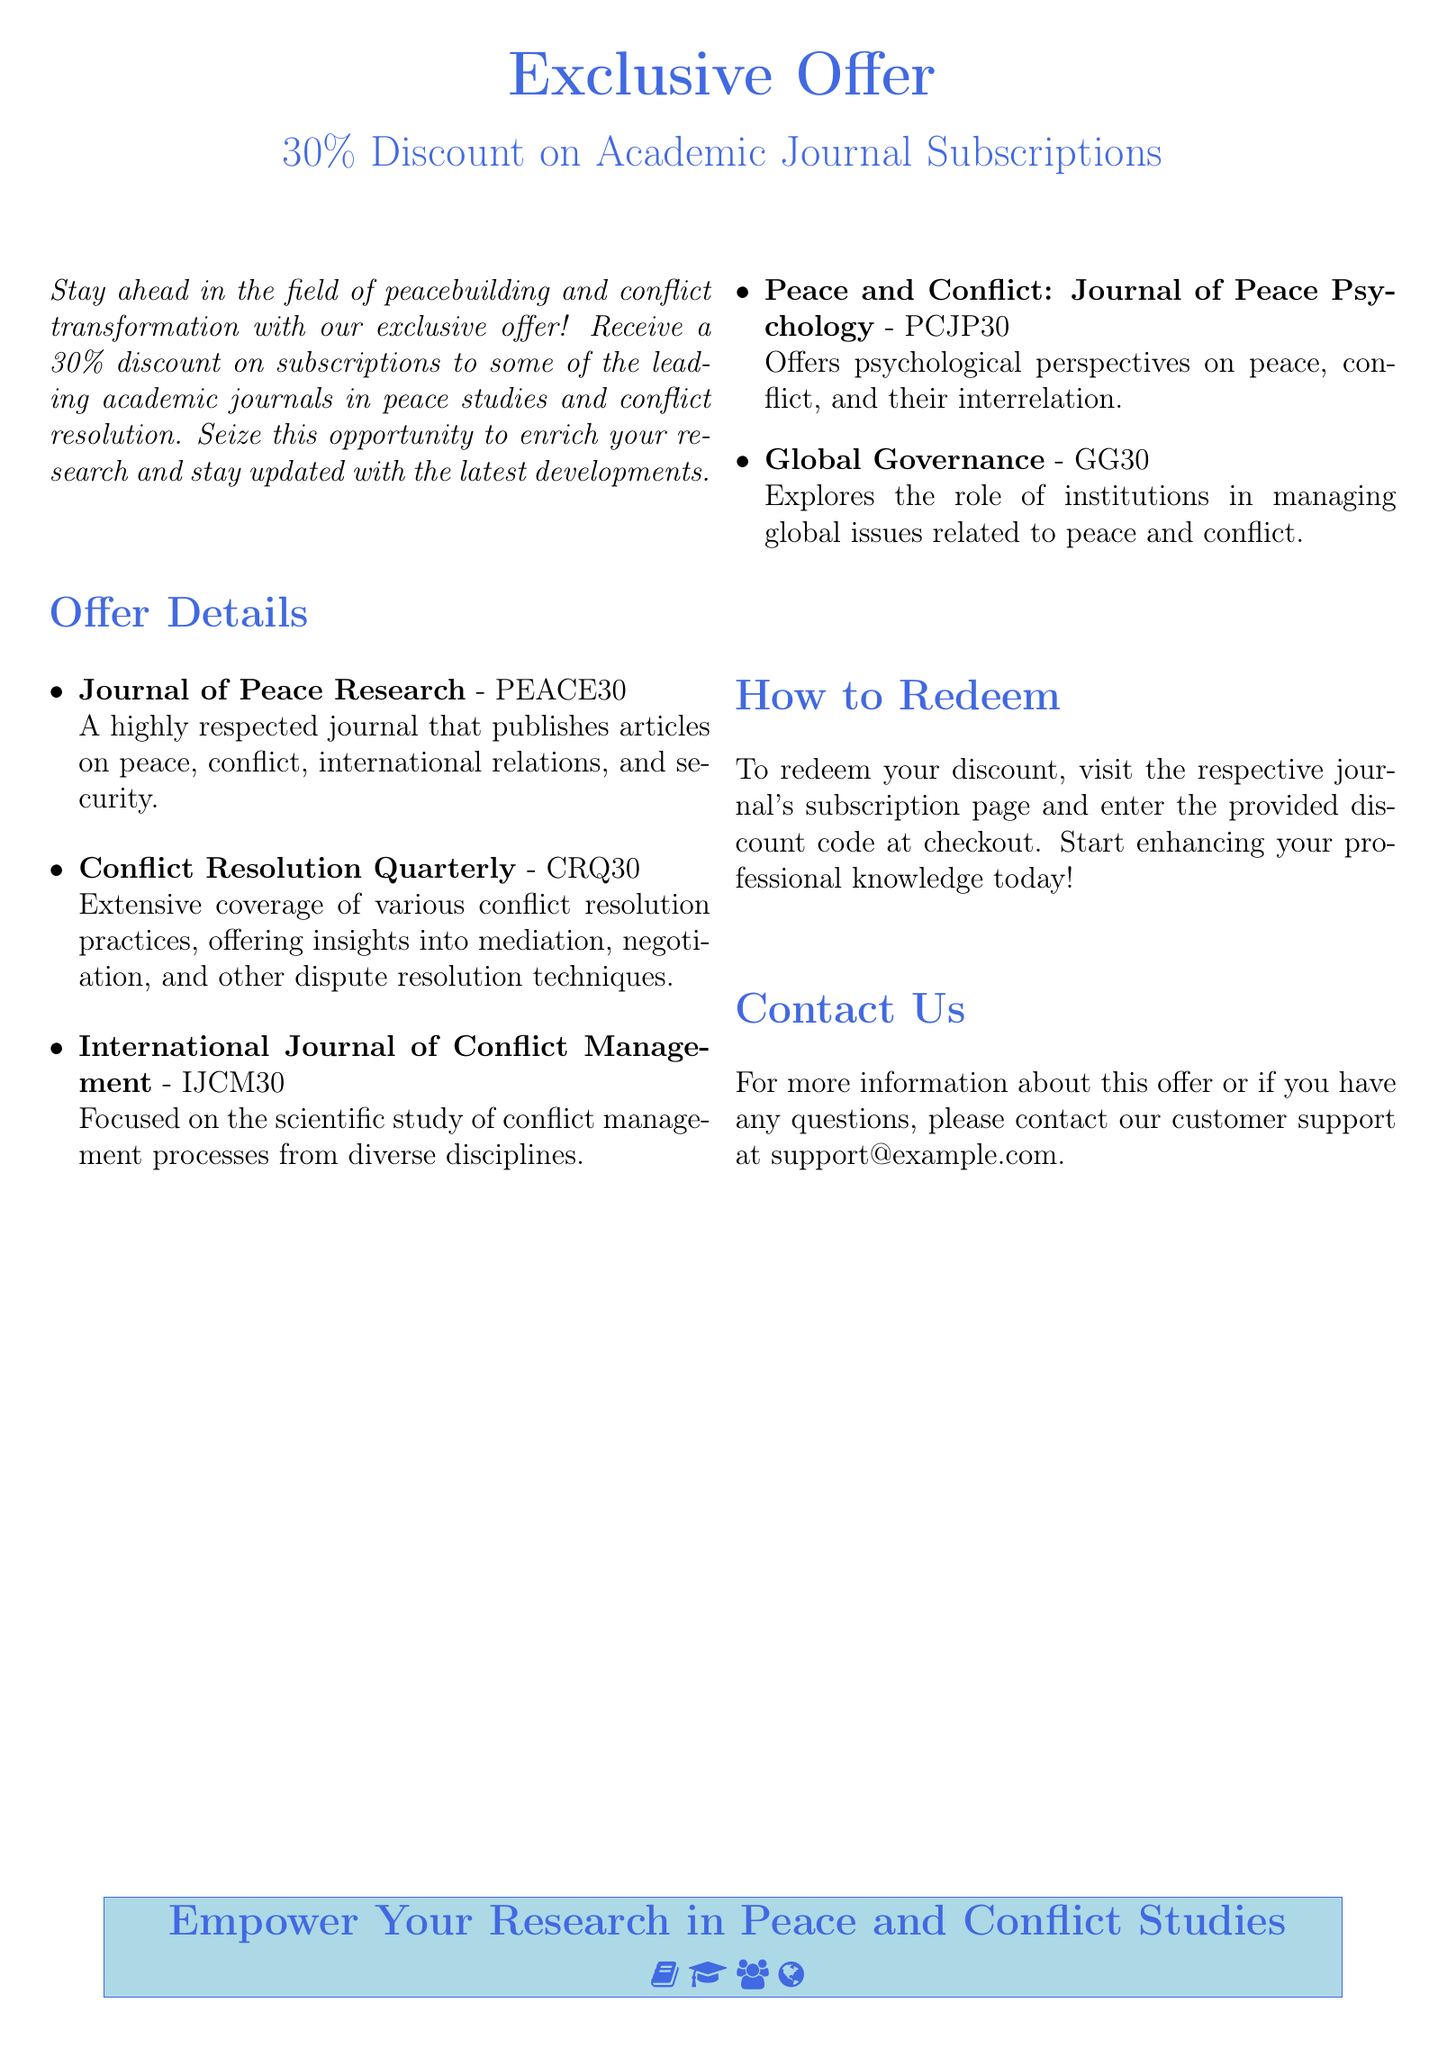What is the discount percentage offered? The document states that a 30% discount is offered on subscriptions.
Answer: 30% What is the name of the journal associated with the code PEACE30? The name of the journal is "Journal of Peace Research."
Answer: Journal of Peace Research Which journal focuses on psychological perspectives? The document identifies "Peace and Conflict: Journal of Peace Psychology" as the journal with psychological perspectives on peace and conflict.
Answer: Peace and Conflict: Journal of Peace Psychology How can you redeem the discount? To redeem, you need to visit the respective journal's subscription page and enter the provided discount code.
Answer: Visit the subscription page What type of offer is presented in the document? The offer is an exclusive discount on academic journal subscriptions related to peace studies and conflict resolution.
Answer: Exclusive offer What is the email address for customer support? The document provides the customer support email as support@example.com.
Answer: support@example.com Which journal provides insights into mediation and negotiation? "Conflict Resolution Quarterly" provides extensive coverage on mediation and negotiation practices according to the document.
Answer: Conflict Resolution Quarterly What is the main focus of the "International Journal of Conflict Management"? The focus is on the scientific study of conflict management processes.
Answer: Scientific study of conflict management processes How many journals are listed in the document? The document lists five journals eligible for the discount offer.
Answer: Five journals 